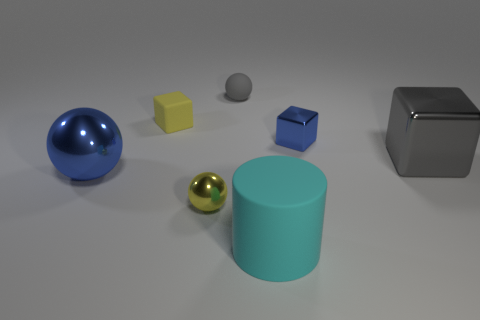Subtract all matte spheres. How many spheres are left? 2 Add 2 blue balls. How many objects exist? 9 Subtract all blue cubes. How many cubes are left? 2 Subtract 1 spheres. How many spheres are left? 2 Subtract all cubes. How many objects are left? 4 Subtract all brown balls. Subtract all green cylinders. How many balls are left? 3 Subtract all cyan matte cylinders. Subtract all large cyan things. How many objects are left? 5 Add 4 yellow shiny objects. How many yellow shiny objects are left? 5 Add 6 yellow cubes. How many yellow cubes exist? 7 Subtract 0 red blocks. How many objects are left? 7 